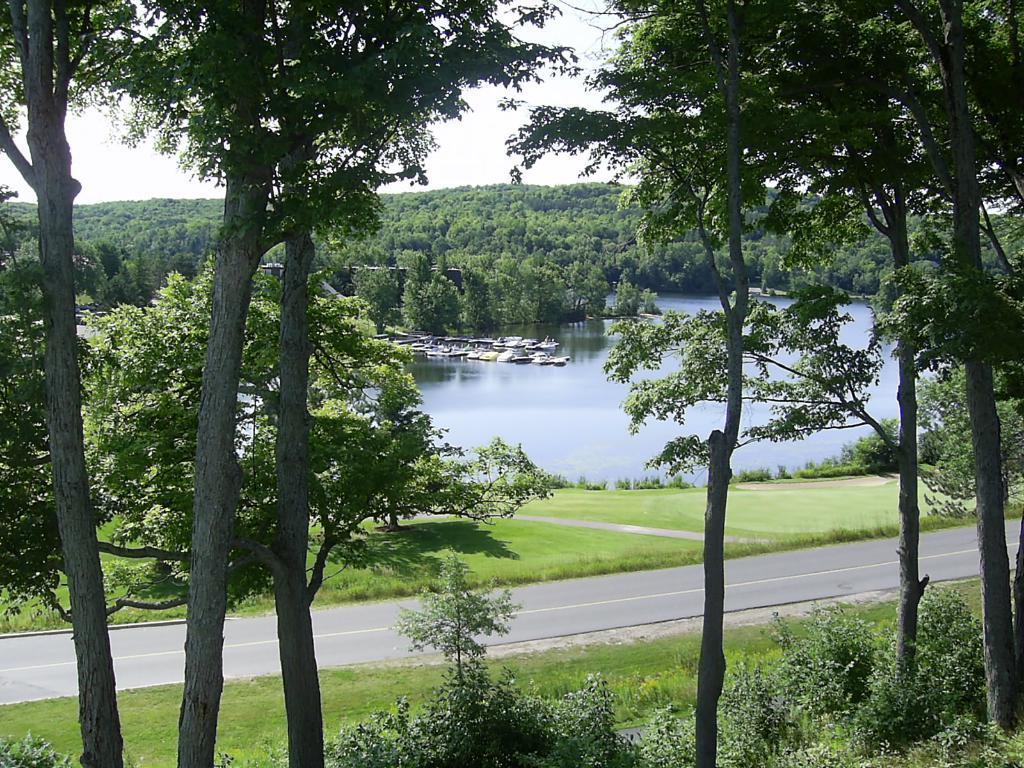In one or two sentences, can you explain what this image depicts? In this image I can see the road. On both sides of the road I can see many trees. In the background I can see few boats on the water. I can also see few more trees and the sky. 